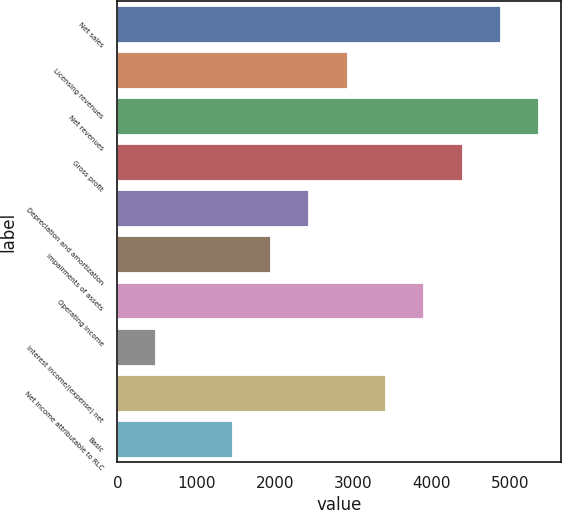Convert chart to OTSL. <chart><loc_0><loc_0><loc_500><loc_500><bar_chart><fcel>Net sales<fcel>Licensing revenues<fcel>Net revenues<fcel>Gross profit<fcel>Depreciation and amortization<fcel>Impairments of assets<fcel>Operating income<fcel>Interest income/(expense) net<fcel>Net income attributable to RLC<fcel>Basic<nl><fcel>4880.1<fcel>2928.14<fcel>5368.09<fcel>4392.11<fcel>2440.15<fcel>1952.16<fcel>3904.12<fcel>488.19<fcel>3416.13<fcel>1464.17<nl></chart> 